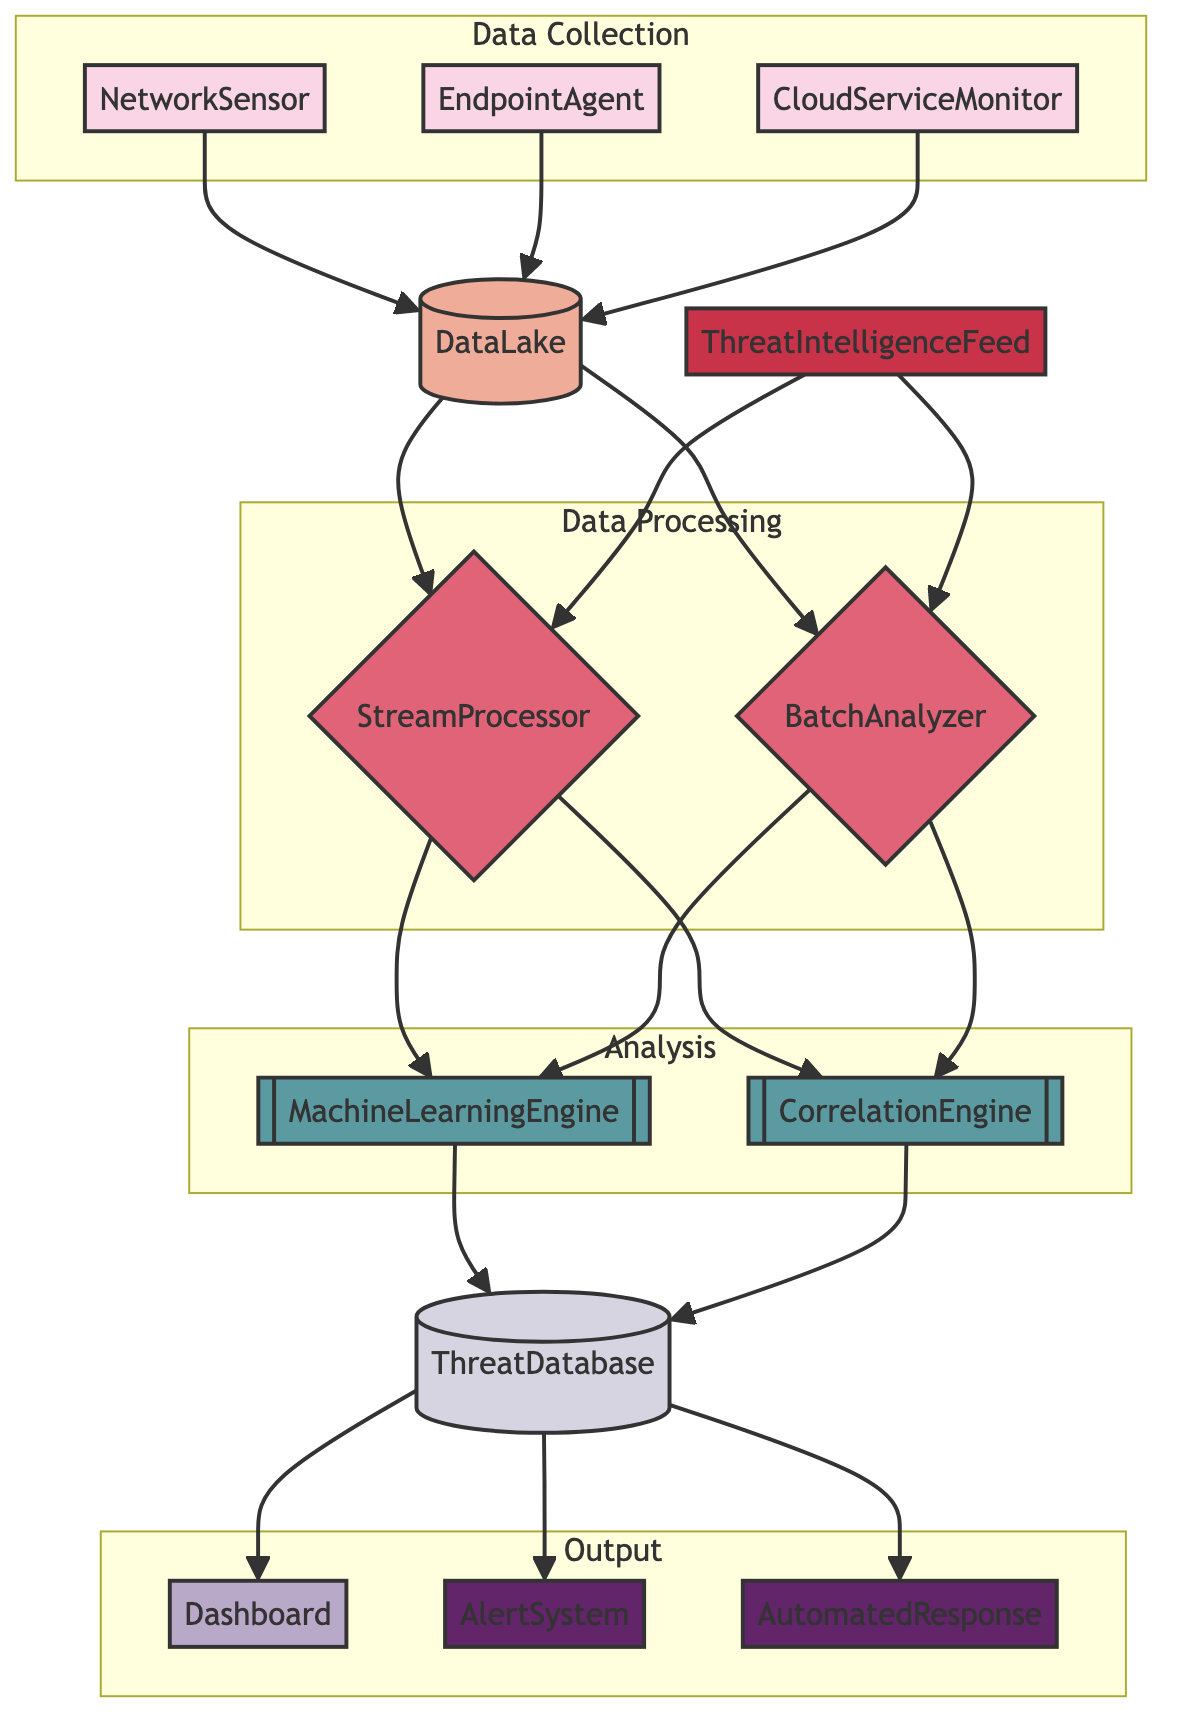What are the types of data collection points in the diagram? The diagram lists three data collection points: NetworkSensor, EndpointAgent, and CloudServiceMonitor. These points are categorized and visually distinct in the flowchart.
Answer: NetworkSensor, EndpointAgent, CloudServiceMonitor What is the purpose of the DataLake? The DataLake serves as centralized storage for raw and semi-processed data collected from various sources, functioning as an essential hub in the data flow architecture.
Answer: Centralized storage for raw and semi-processed data How many analysis subsystems are present in the diagram? The diagram contains two analysis subsystems: MachineLearningEngine and CorrelationEngine. By counting them, it is clear how many distinct analysis processes are at play.
Answer: 2 What type of output does the AlertSystem provide? The AlertSystem generates alerts based on detected threats and anomaly patterns, emphasizing its role in taking action based on analyzed data.
Answer: Alerts Which data processing system takes input from both the DataLake and the ThreatIntelligenceFeed? The StreamProcessor receives inputs from both the DataLake and the ThreatIntelligenceFeed, indicating it processes real-time data with enriched information.
Answer: StreamProcessor What is the final output from the ThreatDatabase? The ThreatDatabase outputs to the Dashboard, AlertSystem, and AutomatedResponse. This shows that it contributes to both visual representation and actionable threat response.
Answer: Dashboard, AlertSystem, AutomatedResponse What is the function of the BatchAnalyzer? The BatchAnalyzer conducts in-depth analysis on batch data to identify potential threats, highlighting its specific role in the data analysis process.
Answer: Conducts in-depth analysis on batch data How does the data flow from the DataLake to the analysis subsystems? Data flows from the DataLake to both the StreamProcessor and BatchAnalyzer before moving on to the analysis subsystems (MachineLearningEngine and CorrelationEngine), depicting the hierarchical structure of data analysis.
Answer: To StreamProcessor and BatchAnalyzer What feeds into the CorrelationEngine? The CorrelationEngine receives input from both the StreamProcessor and BatchAnalyzer, which signifies its function in correlating various forms of analyzed data to identify complex threats.
Answer: StreamProcessor and BatchAnalyzer 